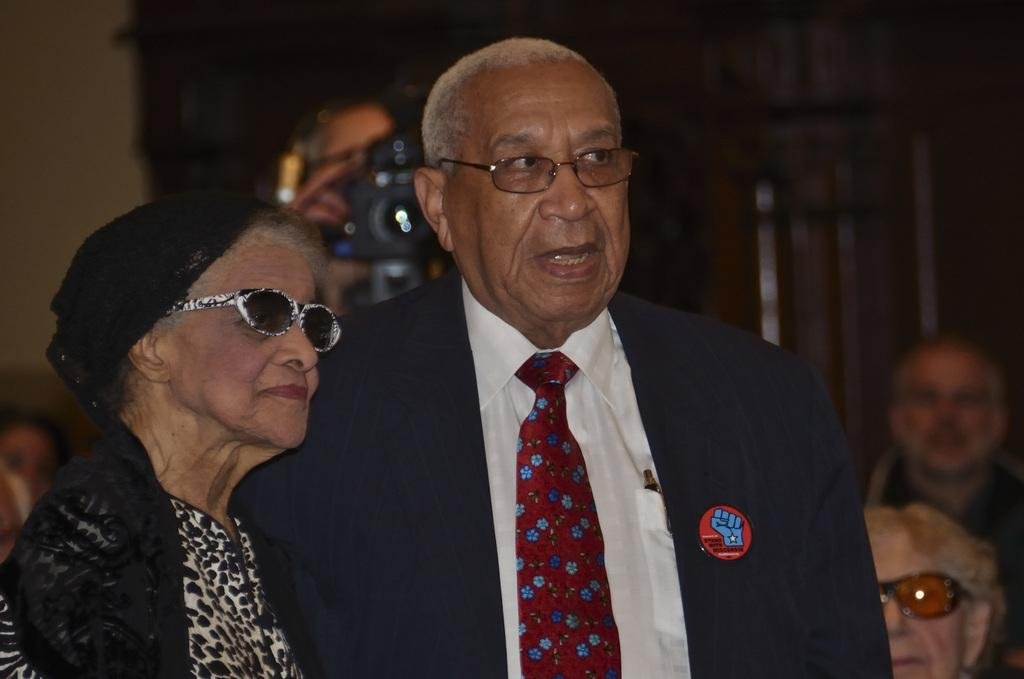Who can be seen in the image? There is a couple in the image. What do both individuals in the couple have in common? Both individuals in the couple are wearing spectacles. How is the man dressed in the image? The man is wearing a coat and a tie. Can you describe the setting of the image? There are people in the background of the image. What type of comb is the man using on his brain in the image? There is no comb or brain visible in the image; the man is wearing a coat and a tie, and both individuals in the couple are wearing spectacles. 